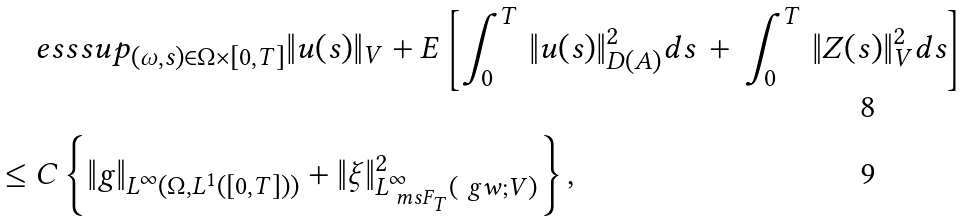<formula> <loc_0><loc_0><loc_500><loc_500>& \ e s s s u p _ { ( \omega , s ) \in \Omega \times [ 0 , T ] } \| u ( s ) \| _ { V } + E \left [ \int _ { 0 } ^ { T } \, \| u ( s ) \| _ { D ( A ) } ^ { 2 } d s \, + \, \int _ { 0 } ^ { T } \, \| Z ( s ) \| _ { V } ^ { 2 } d s \right ] \\ \leq & \ C \left \{ \| g \| _ { L ^ { \infty } ( \Omega , L ^ { 1 } ( [ 0 , T ] ) ) } + \| \xi \| _ { L _ { \ m s { F } _ { T } } ^ { \infty } ( \ g w ; V ) } ^ { 2 } \right \} ,</formula> 